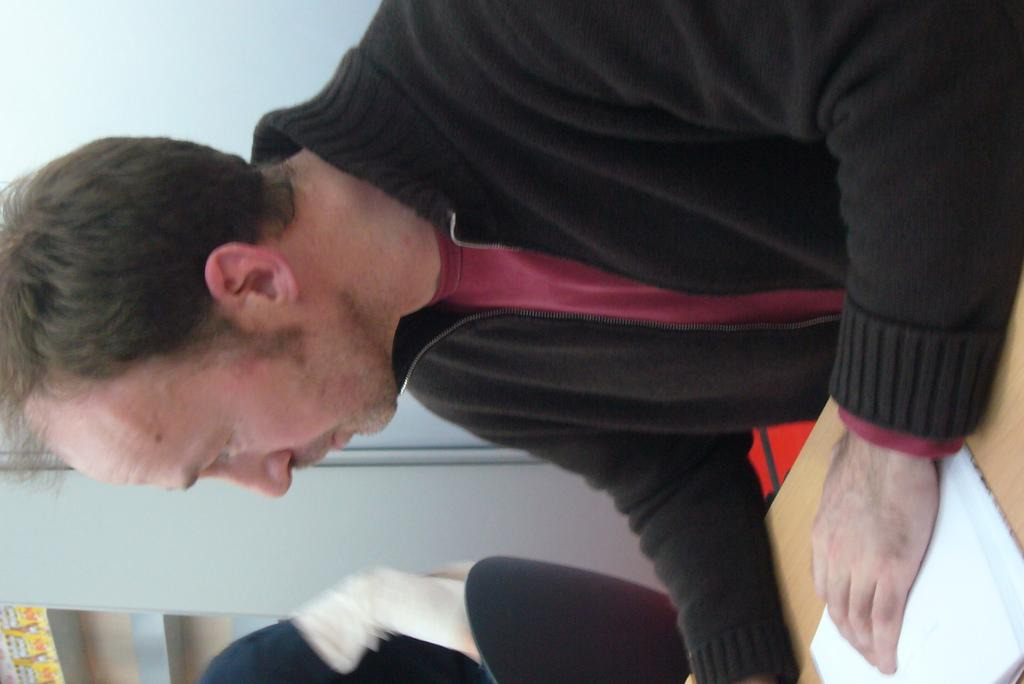What is the man in the image doing? The man is seated in the image. What object is on the table in the image? There is a book on the table in the image. What color is the coat the man is wearing? The man is wearing a black coat. How many people are seated in the image? There are two people seated in the image. What type of meal is the man wishing for in the image? There is no indication in the image that the man is wishing for a meal or expressing any desires. 